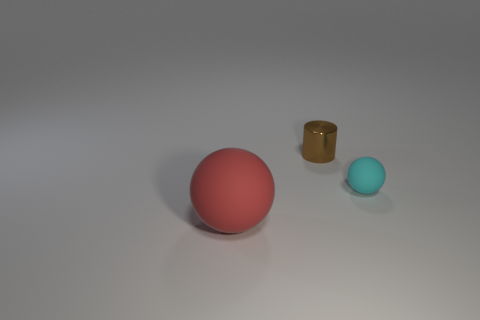Add 3 big brown shiny cylinders. How many objects exist? 6 Subtract all spheres. How many objects are left? 1 Add 1 large gray rubber cylinders. How many large gray rubber cylinders exist? 1 Subtract 1 brown cylinders. How many objects are left? 2 Subtract all green cylinders. Subtract all tiny cyan matte balls. How many objects are left? 2 Add 2 red things. How many red things are left? 3 